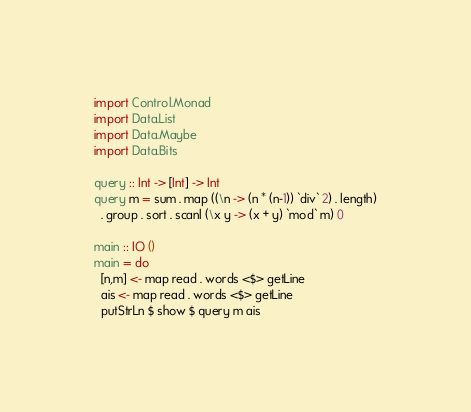Convert code to text. <code><loc_0><loc_0><loc_500><loc_500><_Haskell_>import Control.Monad
import Data.List
import Data.Maybe
import Data.Bits

query :: Int -> [Int] -> Int
query m = sum . map ((\n -> (n * (n-1)) `div` 2) . length)
  . group . sort . scanl (\x y -> (x + y) `mod` m) 0 

main :: IO ()
main = do
  [n,m] <- map read . words <$> getLine
  ais <- map read . words <$> getLine
  putStrLn $ show $ query m ais</code> 